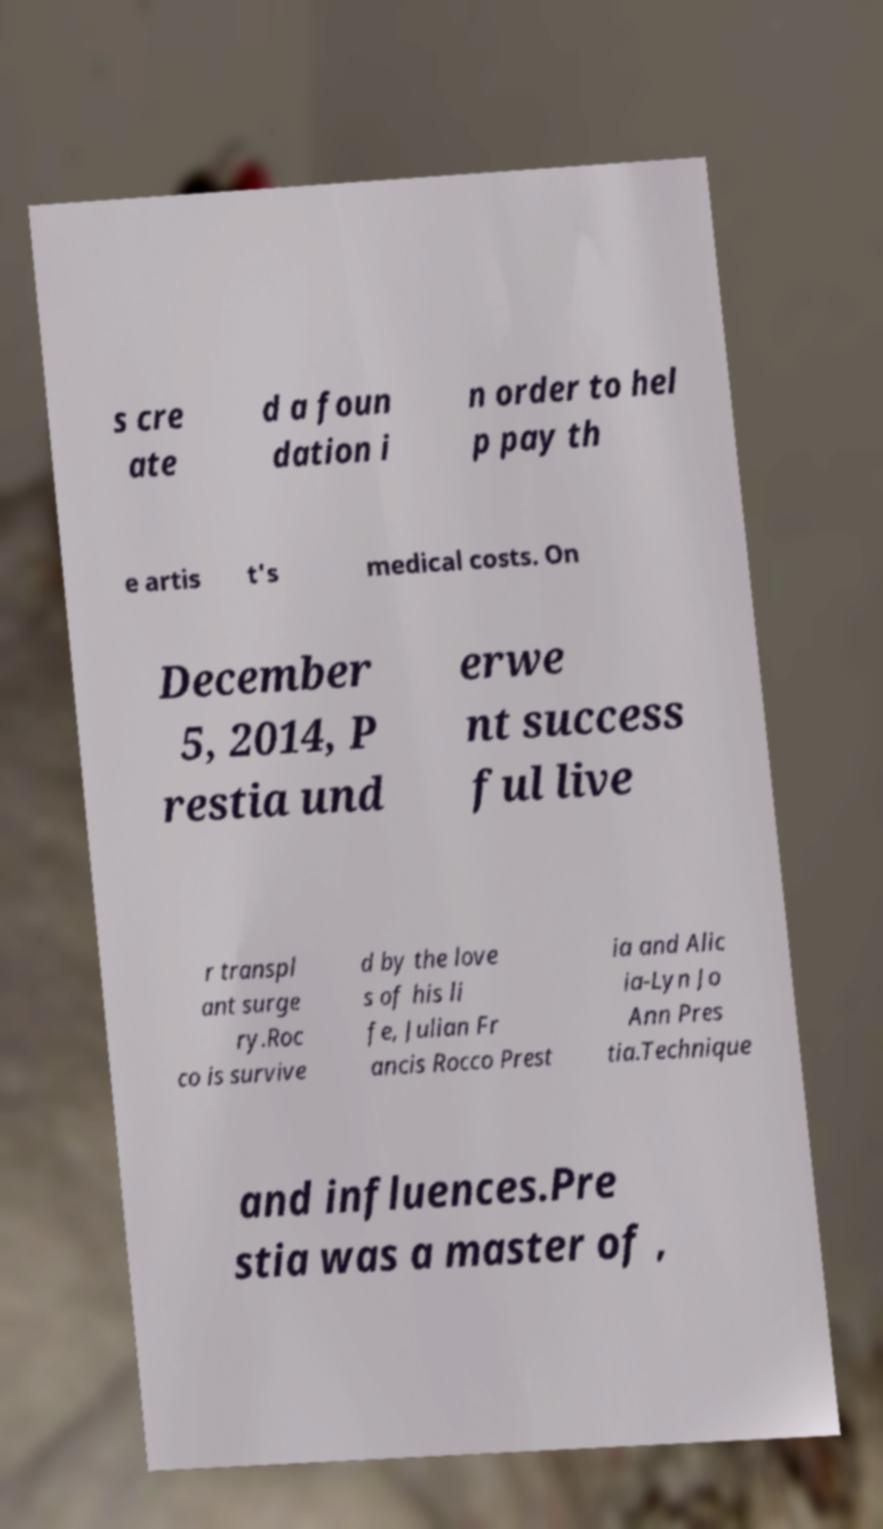For documentation purposes, I need the text within this image transcribed. Could you provide that? s cre ate d a foun dation i n order to hel p pay th e artis t's medical costs. On December 5, 2014, P restia und erwe nt success ful live r transpl ant surge ry.Roc co is survive d by the love s of his li fe, Julian Fr ancis Rocco Prest ia and Alic ia-Lyn Jo Ann Pres tia.Technique and influences.Pre stia was a master of , 